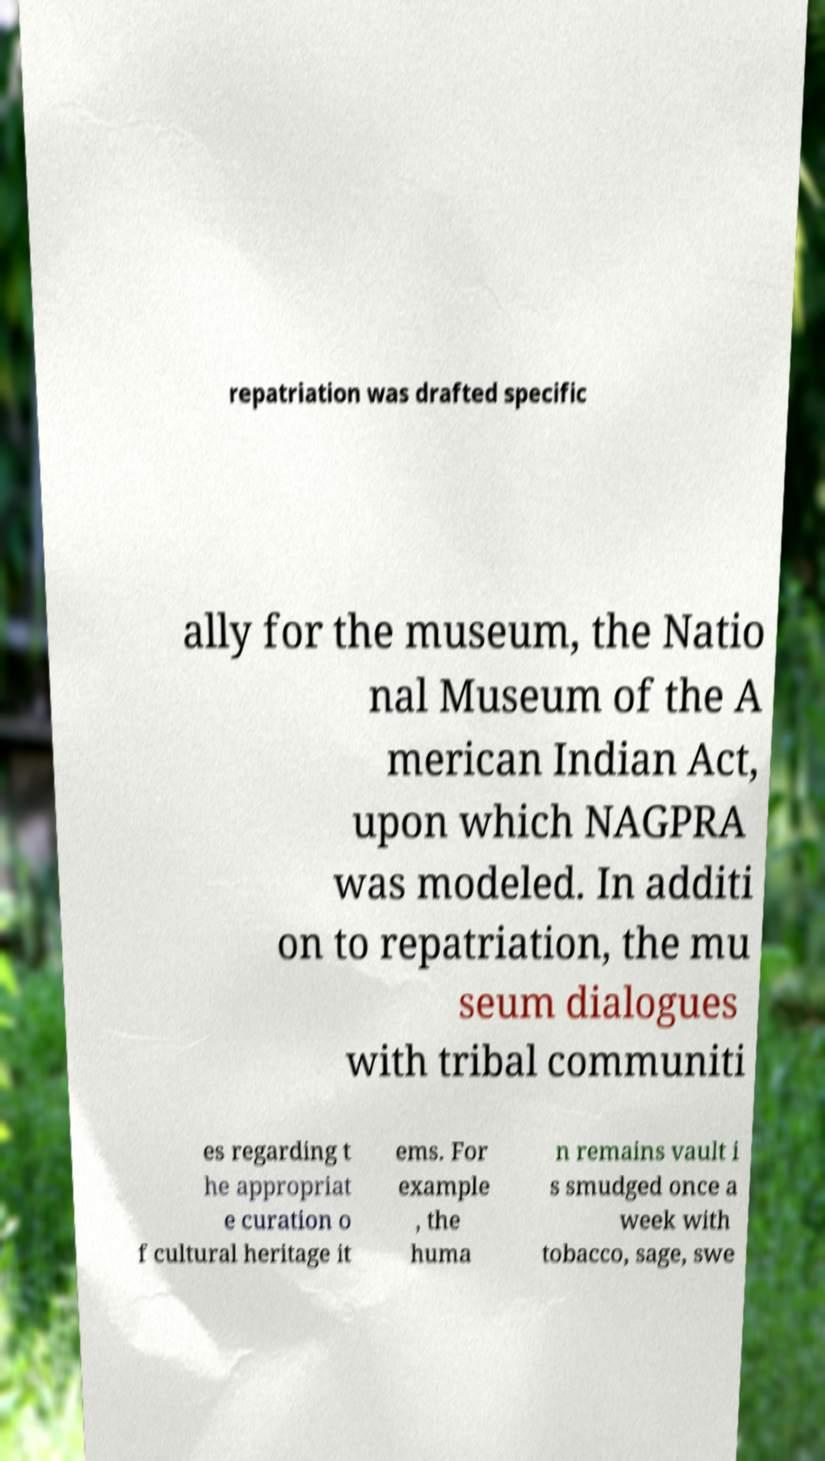Could you extract and type out the text from this image? repatriation was drafted specific ally for the museum, the Natio nal Museum of the A merican Indian Act, upon which NAGPRA was modeled. In additi on to repatriation, the mu seum dialogues with tribal communiti es regarding t he appropriat e curation o f cultural heritage it ems. For example , the huma n remains vault i s smudged once a week with tobacco, sage, swe 